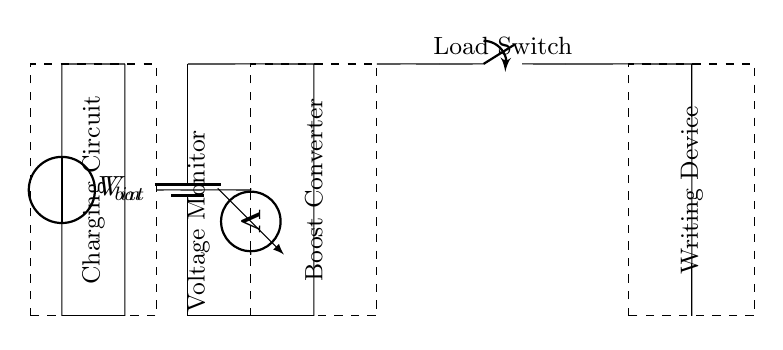What is the role of the boost converter in this circuit? The boost converter's role is to step up the battery voltage to a higher voltage level suitable for the writing device, ensuring it operates effectively.
Answer: Step up voltage What component monitors the battery voltage? The voltage monitor is the component responsible for checking the battery voltage to ensure it remains within the acceptable limits for safe operation of the circuit.
Answer: Voltage monitor What is the function of the load switch? The load switch controls the connection between the power source and the writing device, allowing the user to turn the device on or off as needed.
Answer: Control power supply How does the charging circuit connect to the battery? The charging circuit connects to the battery via a short connection that allows the battery to be charged when power is supplied from the input voltage source.
Answer: Short connection Describe the power source of the charging circuit. The power source for the charging circuit is a voltage source, which provides the necessary input voltage for charging the battery when the device is plugged in.
Answer: Voltage source What does the dashed rectangle around the boost converter indicate? The dashed rectangle signifies the physical boundaries of the boost converter component, helping to visually separate it from other components in the circuit for clarity.
Answer: Component boundary What happens if the voltage monitor detects low battery levels? If the voltage monitor detects low battery levels, it likely triggers an alert or shuts down the load switch to prevent damage to the circuit or writing device.
Answer: Prevents damage 